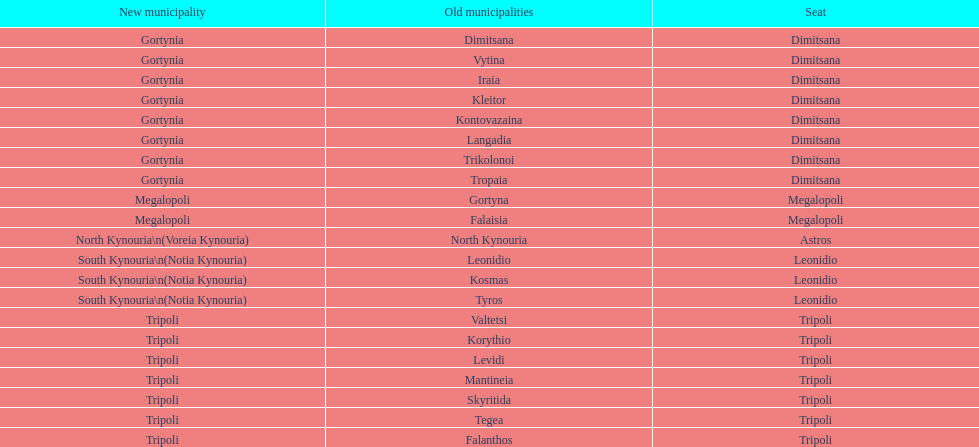What was the number of ancient municipalities in tripoli? 8. 